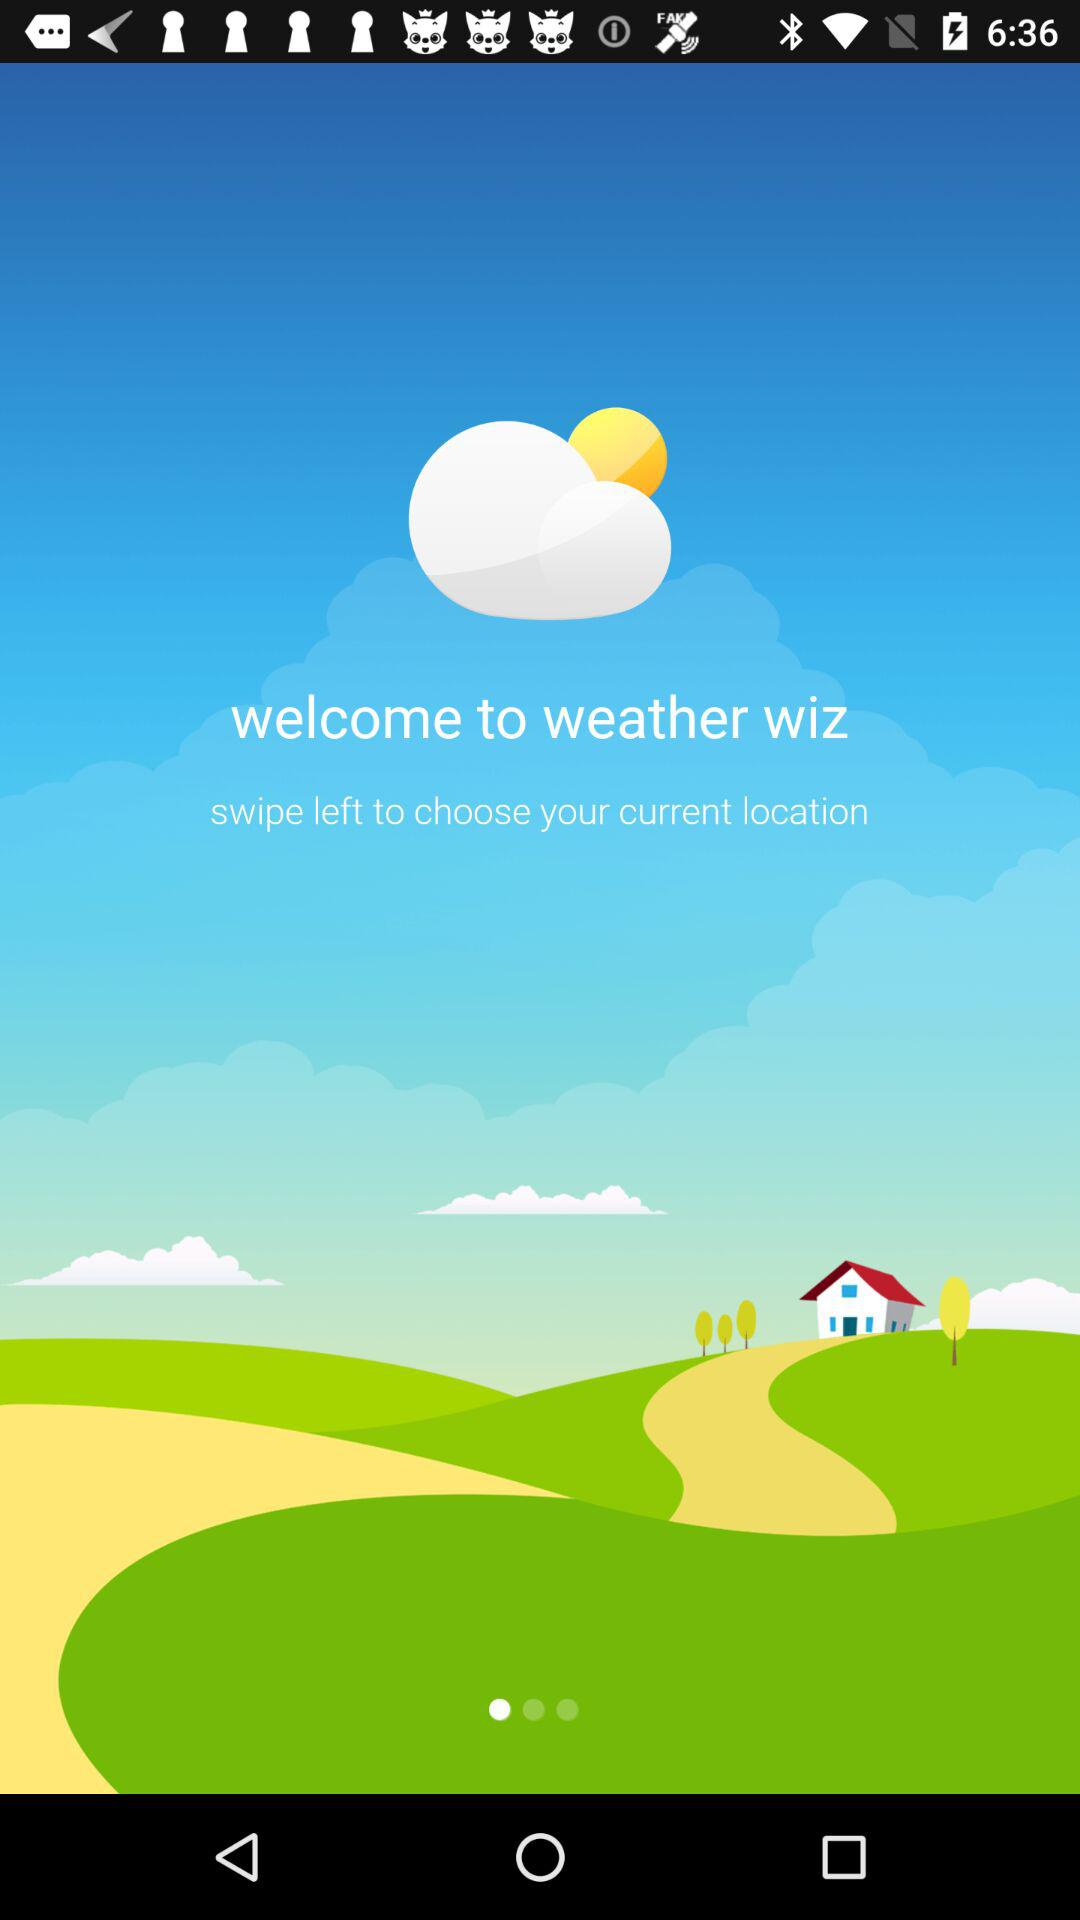What is the application name? The application name is "weather wiz". 